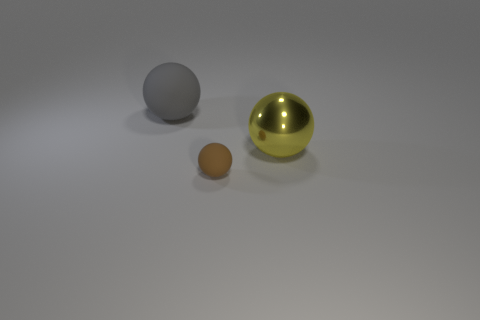Are there any other things that are the same size as the brown thing?
Make the answer very short. No. Are there any other things that have the same material as the large yellow ball?
Give a very brief answer. No. What size is the brown matte thing that is the same shape as the gray rubber thing?
Your response must be concise. Small. Do the small sphere and the large matte sphere have the same color?
Offer a terse response. No. The sphere that is left of the yellow shiny sphere and in front of the large gray matte sphere is what color?
Provide a succinct answer. Brown. What number of things are spheres right of the brown matte ball or large blue rubber blocks?
Offer a terse response. 1. The other big object that is the same shape as the big metal object is what color?
Your answer should be compact. Gray. There is a yellow shiny thing; does it have the same shape as the large thing left of the brown sphere?
Keep it short and to the point. Yes. How many objects are either large gray balls that are behind the large yellow object or things that are on the right side of the large gray sphere?
Your response must be concise. 3. Is the number of tiny brown rubber balls behind the metallic object less than the number of small brown rubber objects?
Your response must be concise. Yes. 